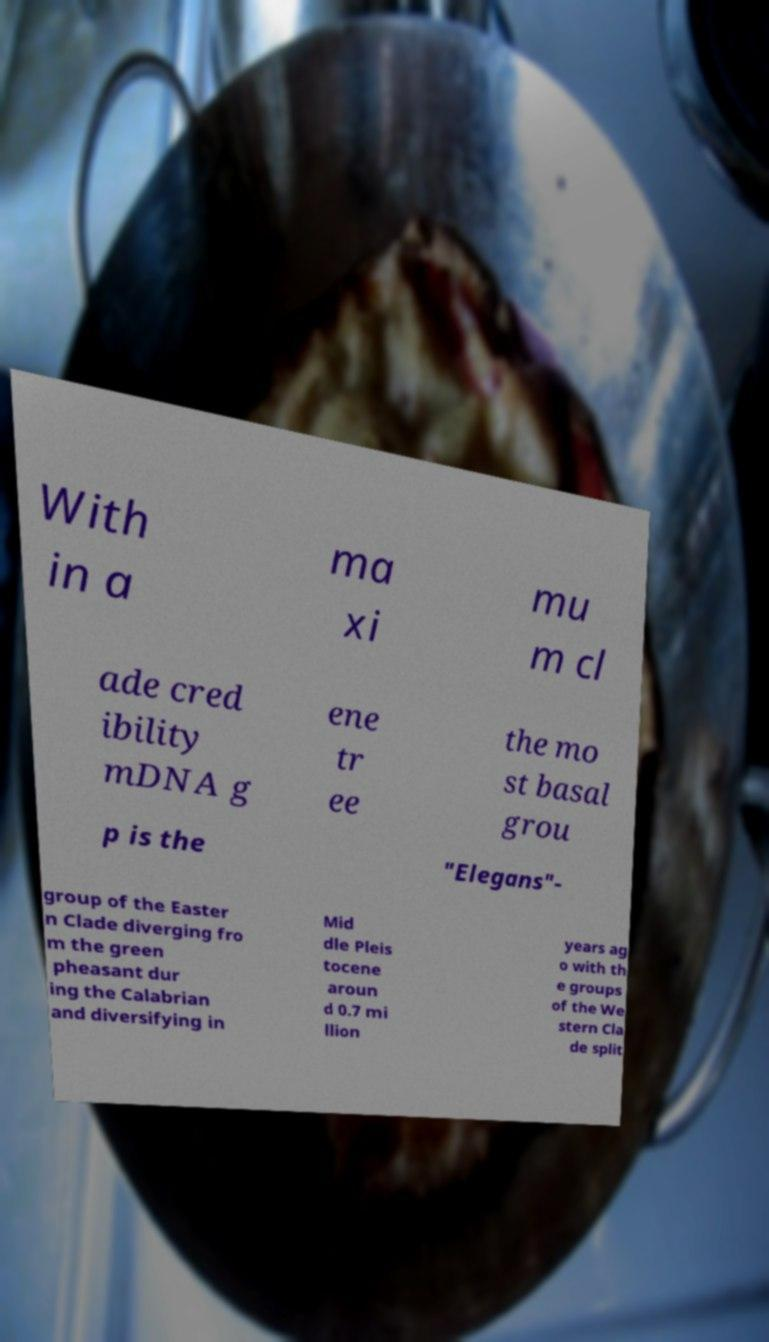Please read and relay the text visible in this image. What does it say? With in a ma xi mu m cl ade cred ibility mDNA g ene tr ee the mo st basal grou p is the "Elegans"- group of the Easter n Clade diverging fro m the green pheasant dur ing the Calabrian and diversifying in Mid dle Pleis tocene aroun d 0.7 mi llion years ag o with th e groups of the We stern Cla de split 